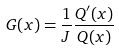<formula> <loc_0><loc_0><loc_500><loc_500>G ( x ) = \frac { 1 } { J } \frac { Q ^ { \prime } ( x ) } { Q ( x ) }</formula> 